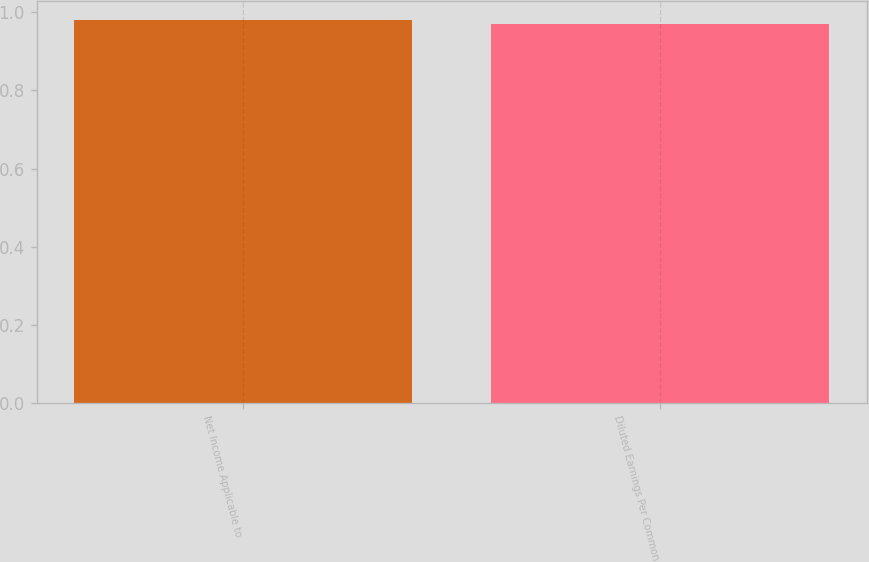Convert chart. <chart><loc_0><loc_0><loc_500><loc_500><bar_chart><fcel>Net Income Applicable to<fcel>Diluted Earnings Per Common<nl><fcel>0.98<fcel>0.97<nl></chart> 